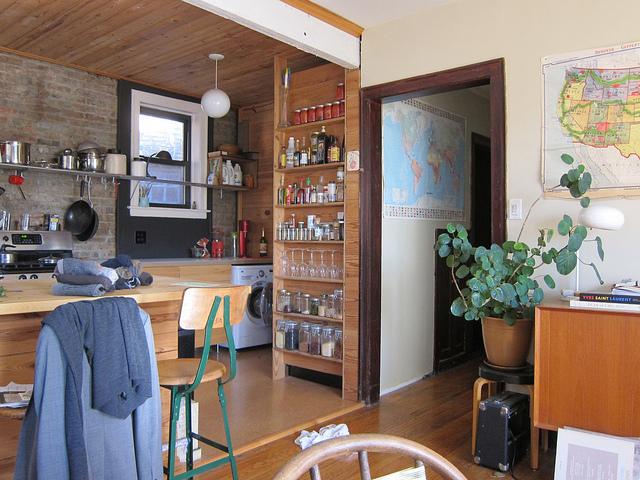How many STEMMED glasses are sitting on the shelves?
Concise answer only. 6. How many maps are there?
Be succinct. 2. Is the style of this room modernist?
Write a very short answer. Yes. Is there a kitchen in the image?
Answer briefly. Yes. 